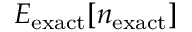<formula> <loc_0><loc_0><loc_500><loc_500>E _ { e x a c t } [ n _ { e x a c t } ]</formula> 